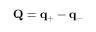Convert formula to latex. <formula><loc_0><loc_0><loc_500><loc_500>Q = q _ { + } - q _ { - }</formula> 